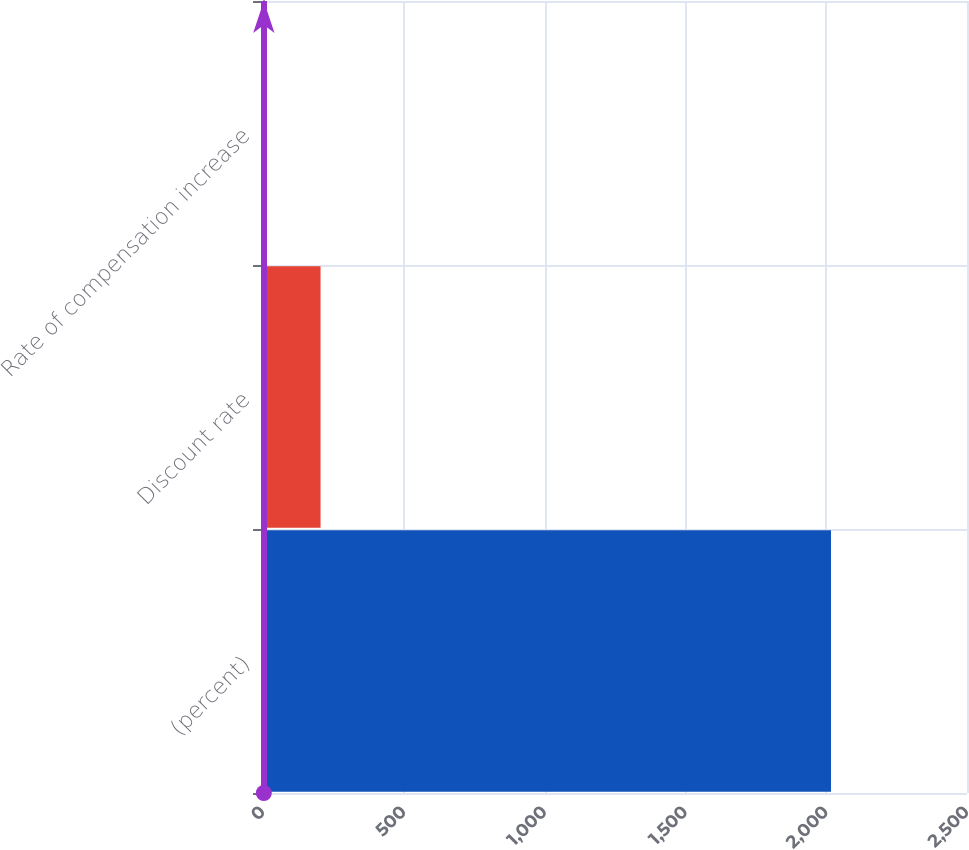Convert chart to OTSL. <chart><loc_0><loc_0><loc_500><loc_500><bar_chart><fcel>(percent)<fcel>Discount rate<fcel>Rate of compensation increase<nl><fcel>2017<fcel>204.38<fcel>2.98<nl></chart> 